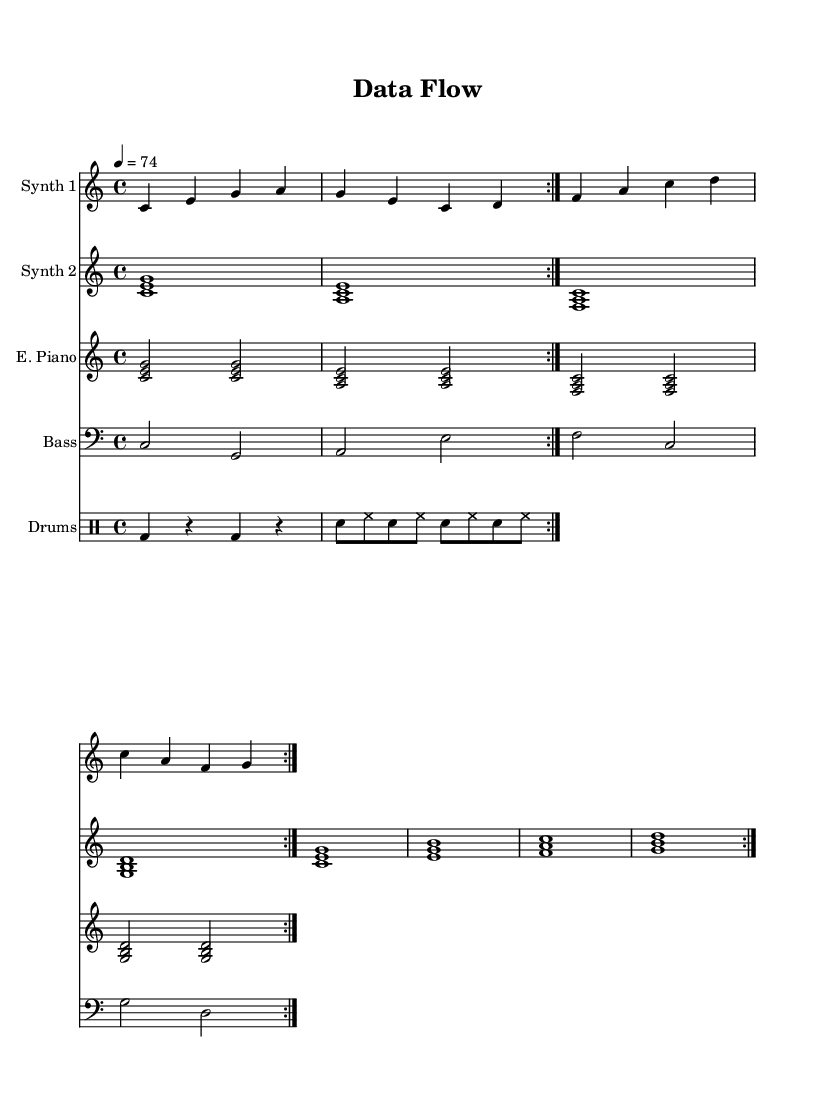What is the key signature of this music? The key signature is indicated at the beginning of the sheet music, showing no sharps or flats; this corresponds to C major.
Answer: C major What is the time signature of the piece? The time signature is displayed at the beginning of the sheet music, indicating a 4/4 time, meaning there are four quarter note beats in each measure.
Answer: 4/4 What is the tempo marking of the music? The tempo marking is found in beats per minute, which is indicated as 74 beats per minute, suggesting a moderately slow pace for this piece.
Answer: 74 How many repetitions are indicated for each section? Each section is marked with a "volta" indicating a repeat, and the music specifies that each section is to be repeated 2 times.
Answer: 2 Which instruments are included in the score? The score includes four staves for different instruments: Synth 1, Synth 2, Electric Piano, and Bass, as well as a DrumStaff for percussion.
Answer: Synth 1, Synth 2, Electric Piano, Bass, Drums What type of electronic music does this sheet represent? This sheet music reflects minimalist electronic music, characterized by repetitive motifs and a focus on creating atmosphere, suitable for concentration.
Answer: Minimalist electronic music 